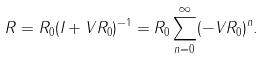Convert formula to latex. <formula><loc_0><loc_0><loc_500><loc_500>R = R _ { 0 } ( I + V R _ { 0 } ) ^ { - 1 } = R _ { 0 } \sum _ { n = 0 } ^ { \infty } ( - V R _ { 0 } ) ^ { n } .</formula> 